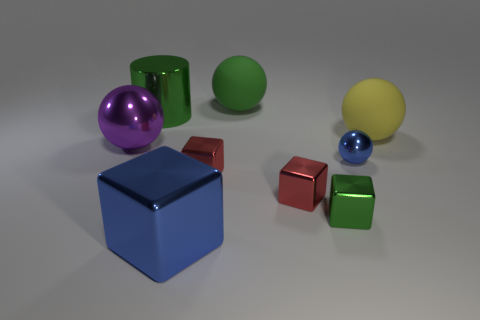Add 1 tiny blue metallic objects. How many objects exist? 10 Subtract all cylinders. How many objects are left? 8 Subtract all large yellow rubber balls. Subtract all green objects. How many objects are left? 5 Add 7 large yellow spheres. How many large yellow spheres are left? 8 Add 5 tiny blue metallic objects. How many tiny blue metallic objects exist? 6 Subtract 0 purple cylinders. How many objects are left? 9 